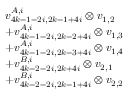Convert formula to latex. <formula><loc_0><loc_0><loc_500><loc_500>\begin{array} { r l } & { v _ { 4 k - 1 - 2 i , 2 k - 1 + 4 i } ^ { A , i } \otimes v _ { 1 , 2 } } \\ & { + v _ { 4 k - 1 - 2 i , 2 k - 2 + 4 i } ^ { A , i } \otimes v _ { 1 , 3 } } \\ & { + v _ { 4 k - 1 - 2 i , 2 k - 3 + 4 i } ^ { A , i } \otimes v _ { 1 , 4 } } \\ & { + v _ { 4 k - 2 - 2 i , 2 k + 4 i } ^ { B , i } \otimes v _ { 2 , 1 } } \\ & { + v _ { 4 k - 2 - 2 i , 2 k - 1 + 4 i } ^ { B , i } \otimes v _ { 2 , 2 } } \end{array}</formula> 